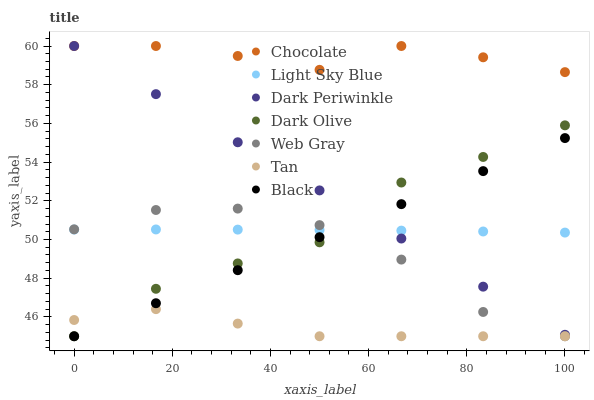Does Tan have the minimum area under the curve?
Answer yes or no. Yes. Does Chocolate have the maximum area under the curve?
Answer yes or no. Yes. Does Dark Olive have the minimum area under the curve?
Answer yes or no. No. Does Dark Olive have the maximum area under the curve?
Answer yes or no. No. Is Black the smoothest?
Answer yes or no. Yes. Is Dark Olive the roughest?
Answer yes or no. Yes. Is Chocolate the smoothest?
Answer yes or no. No. Is Chocolate the roughest?
Answer yes or no. No. Does Web Gray have the lowest value?
Answer yes or no. Yes. Does Chocolate have the lowest value?
Answer yes or no. No. Does Dark Periwinkle have the highest value?
Answer yes or no. Yes. Does Dark Olive have the highest value?
Answer yes or no. No. Is Black less than Chocolate?
Answer yes or no. Yes. Is Chocolate greater than Web Gray?
Answer yes or no. Yes. Does Black intersect Dark Olive?
Answer yes or no. Yes. Is Black less than Dark Olive?
Answer yes or no. No. Is Black greater than Dark Olive?
Answer yes or no. No. Does Black intersect Chocolate?
Answer yes or no. No. 